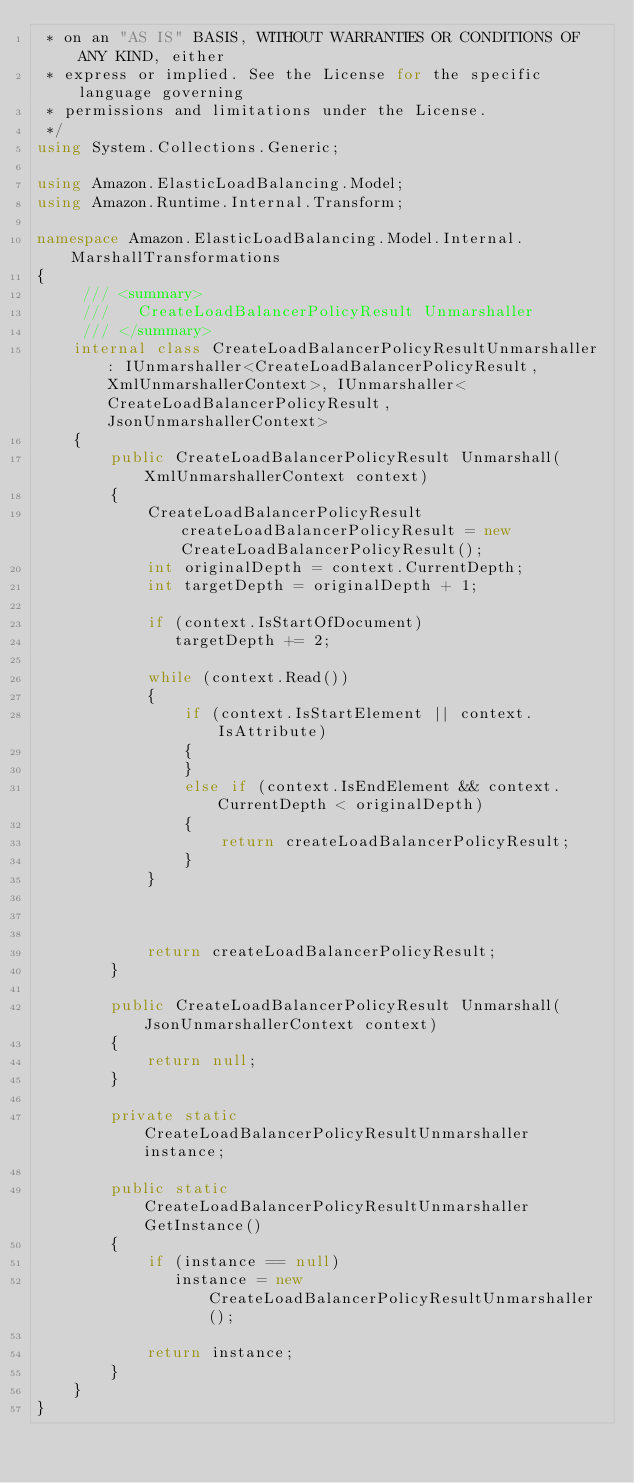Convert code to text. <code><loc_0><loc_0><loc_500><loc_500><_C#_> * on an "AS IS" BASIS, WITHOUT WARRANTIES OR CONDITIONS OF ANY KIND, either
 * express or implied. See the License for the specific language governing
 * permissions and limitations under the License.
 */
using System.Collections.Generic;

using Amazon.ElasticLoadBalancing.Model;
using Amazon.Runtime.Internal.Transform;

namespace Amazon.ElasticLoadBalancing.Model.Internal.MarshallTransformations
{
     /// <summary>
     ///   CreateLoadBalancerPolicyResult Unmarshaller
     /// </summary>
    internal class CreateLoadBalancerPolicyResultUnmarshaller : IUnmarshaller<CreateLoadBalancerPolicyResult, XmlUnmarshallerContext>, IUnmarshaller<CreateLoadBalancerPolicyResult, JsonUnmarshallerContext> 
    {
        public CreateLoadBalancerPolicyResult Unmarshall(XmlUnmarshallerContext context) 
        {
            CreateLoadBalancerPolicyResult createLoadBalancerPolicyResult = new CreateLoadBalancerPolicyResult();
            int originalDepth = context.CurrentDepth;
            int targetDepth = originalDepth + 1;
            
            if (context.IsStartOfDocument) 
               targetDepth += 2;
            
            while (context.Read())
            {
                if (context.IsStartElement || context.IsAttribute)
                {
                }
                else if (context.IsEndElement && context.CurrentDepth < originalDepth)
                {
                    return createLoadBalancerPolicyResult;
                }
            }
                        


            return createLoadBalancerPolicyResult;
        }

        public CreateLoadBalancerPolicyResult Unmarshall(JsonUnmarshallerContext context) 
        {
            return null;
        }

        private static CreateLoadBalancerPolicyResultUnmarshaller instance;

        public static CreateLoadBalancerPolicyResultUnmarshaller GetInstance() 
        {
            if (instance == null) 
               instance = new CreateLoadBalancerPolicyResultUnmarshaller();

            return instance;
        }
    }
}
    
</code> 